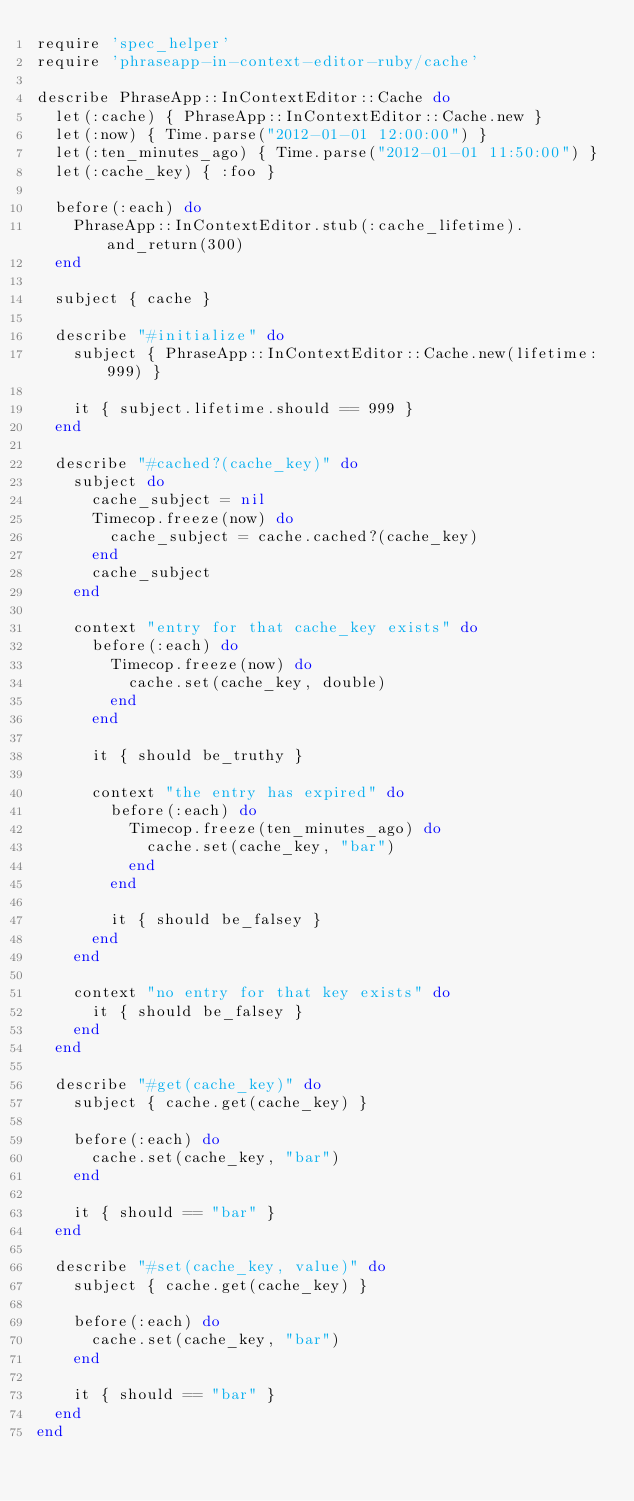Convert code to text. <code><loc_0><loc_0><loc_500><loc_500><_Ruby_>require 'spec_helper'
require 'phraseapp-in-context-editor-ruby/cache'

describe PhraseApp::InContextEditor::Cache do
  let(:cache) { PhraseApp::InContextEditor::Cache.new }
  let(:now) { Time.parse("2012-01-01 12:00:00") }
  let(:ten_minutes_ago) { Time.parse("2012-01-01 11:50:00") }
  let(:cache_key) { :foo }

  before(:each) do
    PhraseApp::InContextEditor.stub(:cache_lifetime).and_return(300)
  end

  subject { cache }

  describe "#initialize" do
    subject { PhraseApp::InContextEditor::Cache.new(lifetime: 999) }

    it { subject.lifetime.should == 999 }
  end

  describe "#cached?(cache_key)" do
    subject do
      cache_subject = nil
      Timecop.freeze(now) do
        cache_subject = cache.cached?(cache_key)
      end
      cache_subject
    end

    context "entry for that cache_key exists" do
      before(:each) do
        Timecop.freeze(now) do
          cache.set(cache_key, double)
        end
      end

      it { should be_truthy }

      context "the entry has expired" do
        before(:each) do
          Timecop.freeze(ten_minutes_ago) do
            cache.set(cache_key, "bar")
          end
        end

        it { should be_falsey }
      end
    end

    context "no entry for that key exists" do
      it { should be_falsey }
    end
  end

  describe "#get(cache_key)" do
    subject { cache.get(cache_key) }

    before(:each) do
      cache.set(cache_key, "bar")
    end

    it { should == "bar" }
  end

  describe "#set(cache_key, value)" do
    subject { cache.get(cache_key) }

    before(:each) do
      cache.set(cache_key, "bar")
    end

    it { should == "bar" }
  end
end
</code> 